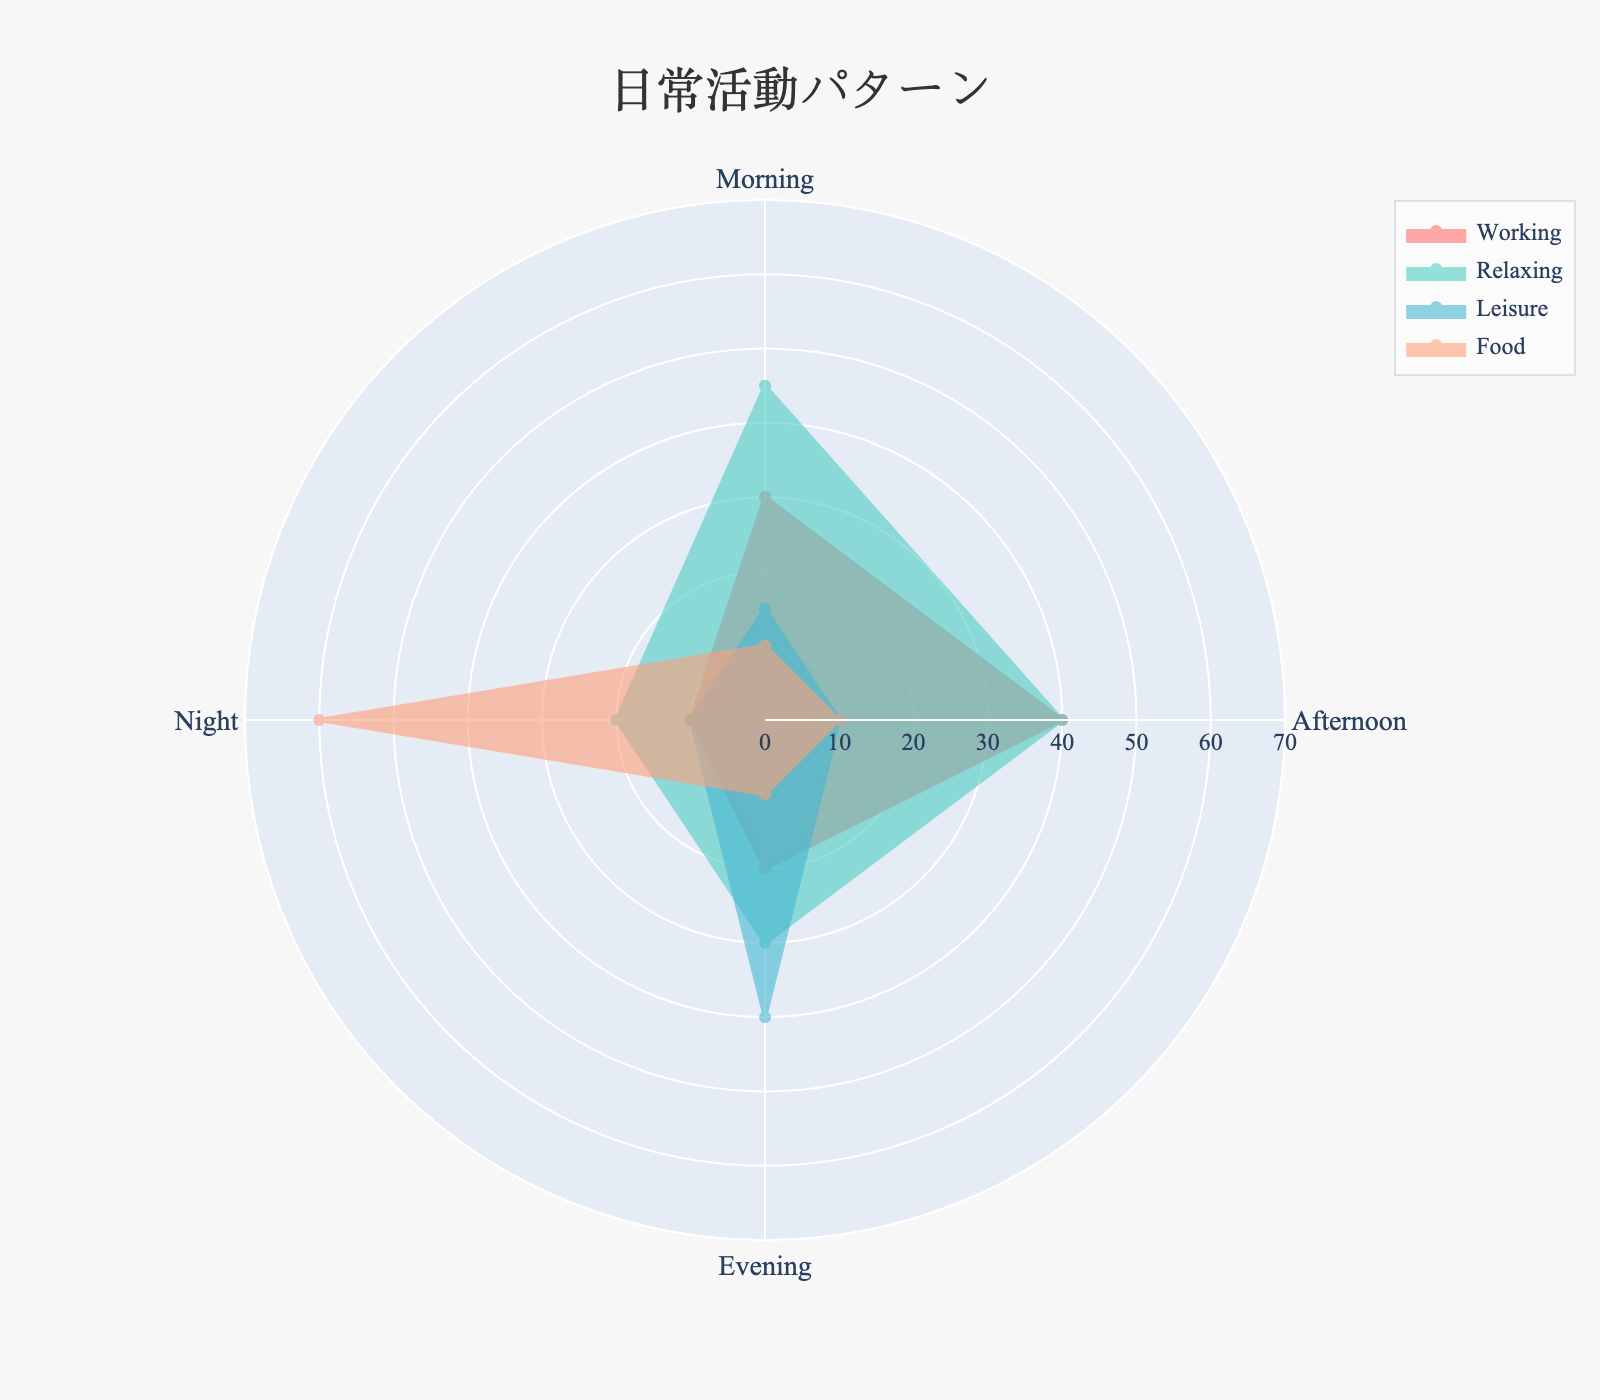What's the title of the radar chart? The text at the top of the chart is the title.
Answer: 日常活動パターン In which time of day is the highest percentage of Leisure activities done? Check each category for the percentage of Leisure and identify the maximum value.
Answer: Evening What's the sum of Working activity percentages for all the time categories? Add the values for Working activity across Morning, Afternoon, Evening, and Night. 30 + 40 + 20 + 10 = 100
Answer: 100 During which time is Food activity the least? Compare the Food activity percentages for Morning, Afternoon, Evening, and Night. Identify the minimum value.
Answer: Morning, Afternoon, Evening Which activity has the highest percentage at Night? Look at the percentages given for each activity in the Night category and identify the highest one.
Answer: Food By how much does the percentage of Relaxing in the Morning exceed Relaxing in the Night? Subtract the percentage of Relaxing in the Night from that in the Morning. 45 - 20 = 25
Answer: 25 Which activity shows the most variability across different times of the day? Assess all activities and identify which one has the widest range of values.
Answer: Food Do any activities have the same percentage value during different time periods? Review the data to find any matching percentages across different time categories for each activity.
Answer: Yes, Food has 10% in Morning, Afternoon, and Evening How does the percentage of Working in the Afternoon compare to that in the Night? Compare the percentage values of Working activity in the Afternoon and Night.
Answer: Higher 